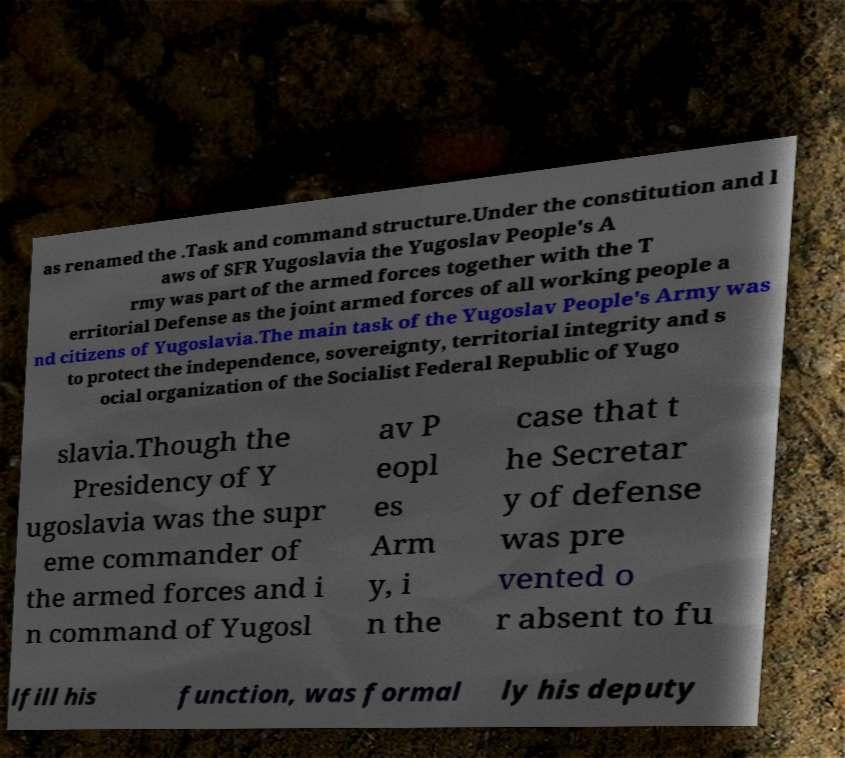Can you read and provide the text displayed in the image?This photo seems to have some interesting text. Can you extract and type it out for me? as renamed the .Task and command structure.Under the constitution and l aws of SFR Yugoslavia the Yugoslav People's A rmy was part of the armed forces together with the T erritorial Defense as the joint armed forces of all working people a nd citizens of Yugoslavia.The main task of the Yugoslav People's Army was to protect the independence, sovereignty, territorial integrity and s ocial organization of the Socialist Federal Republic of Yugo slavia.Though the Presidency of Y ugoslavia was the supr eme commander of the armed forces and i n command of Yugosl av P eopl es Arm y, i n the case that t he Secretar y of defense was pre vented o r absent to fu lfill his function, was formal ly his deputy 